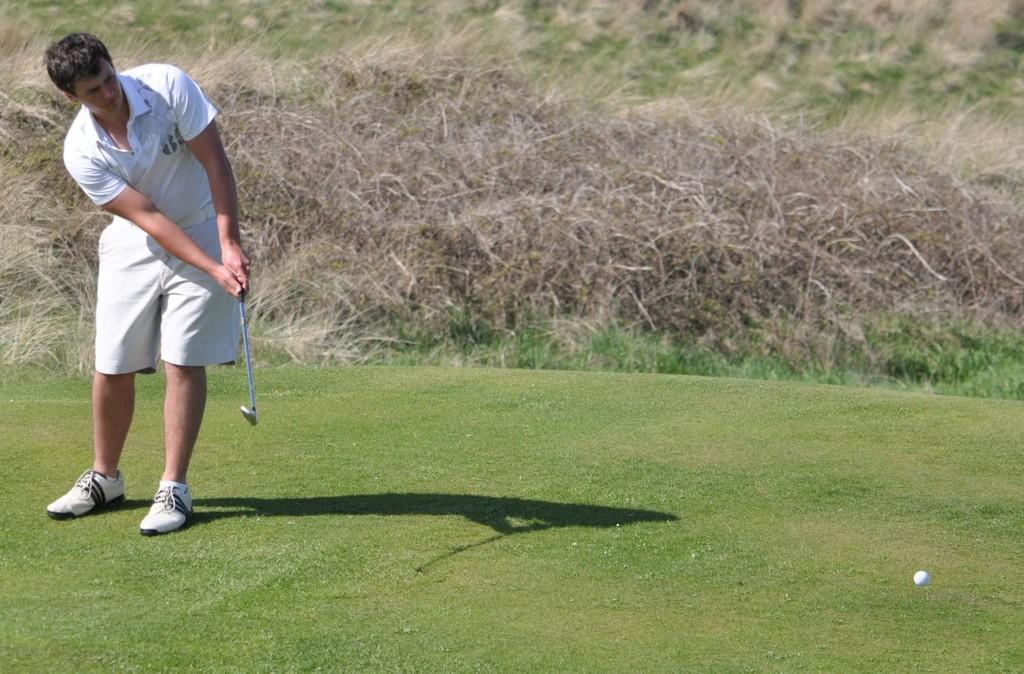Who or what is present in the image? There is a person in the image. What is the person holding in the image? The person is holding a golf club. Can you describe any additional features in the image? There is a shadow of the person in the image, as well as a ball and grass in the background. What type of stick is the person using to hit the baseball in the image? There is no baseball or stick present in the image; the person is holding a golf club. 